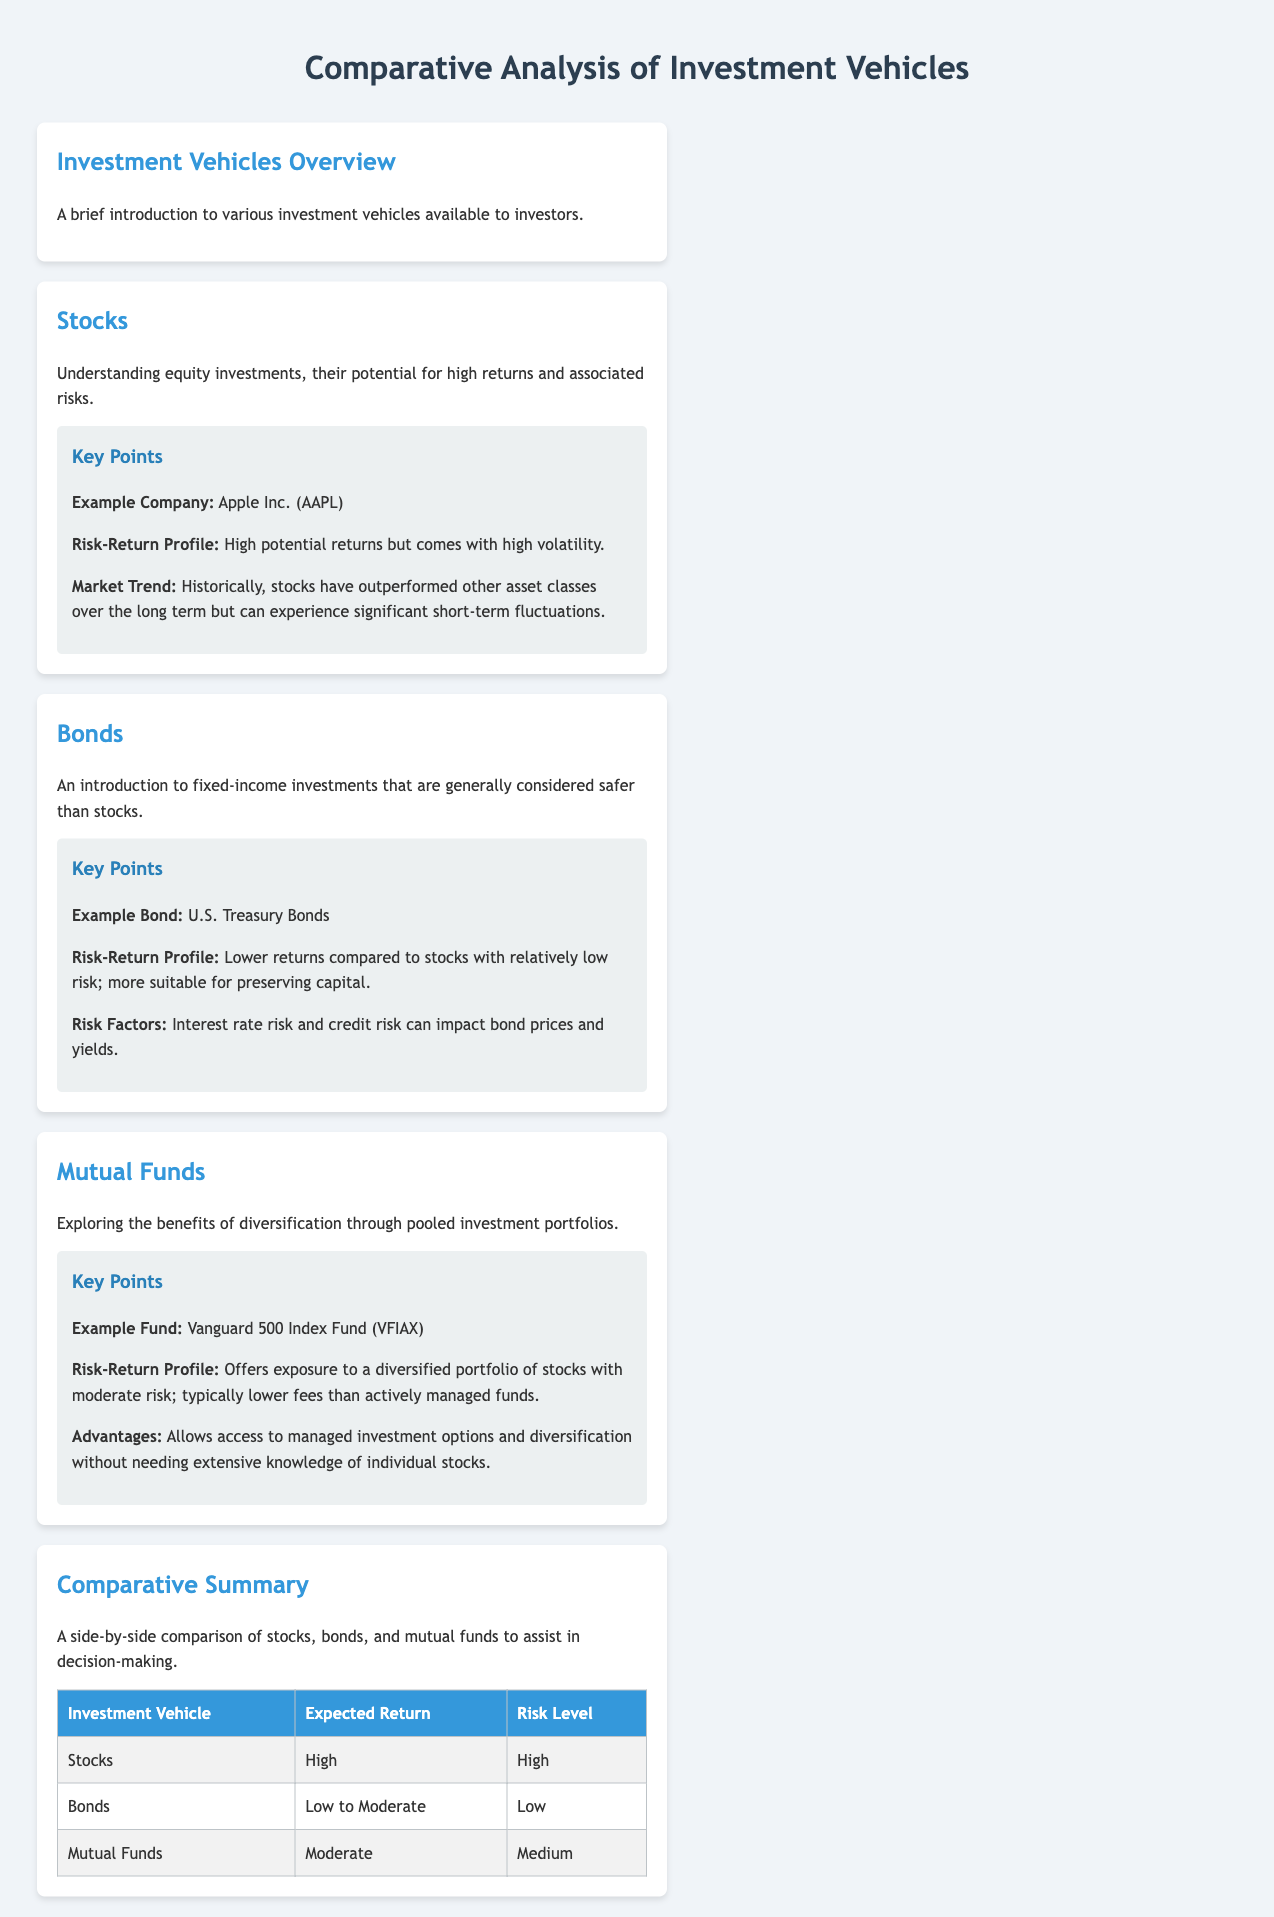What is the example company given for stocks? The document provides Apple Inc. (AAPL) as the example company for stocks.
Answer: Apple Inc. (AAPL) What is the expected return for bonds? According to the comparative summary, bonds are classified as having a low to moderate expected return.
Answer: Low to Moderate What is the risk level associated with mutual funds? In the comparative summary, the risk level of mutual funds is identified as medium.
Answer: Medium What asset class has historically outperformed others? The document states that historically, stocks have outperformed other asset classes over the long term.
Answer: Stocks What is a key advantage of mutual funds mentioned? The text highlights that mutual funds allow access to managed investment options and diversification without needing extensive knowledge of individual stocks.
Answer: Diversification What is the risk-return profile of bonds? The document describes bonds as having lower returns compared to stocks with relatively low risk.
Answer: Lower returns, low risk Which investment vehicle is associated with the Vanguard 500 Index Fund? The document references the Vanguard 500 Index Fund (VFIAX) as an example of mutual funds.
Answer: Mutual Funds Which type of investment is described as having high volatility? The document specifically notes that stocks come with high volatility as part of their risk-return profile.
Answer: Stocks What are the risk factors associated with bonds? The document mentions interest rate risk and credit risk as factors that can impact bond prices and yields.
Answer: Interest rate risk and credit risk 